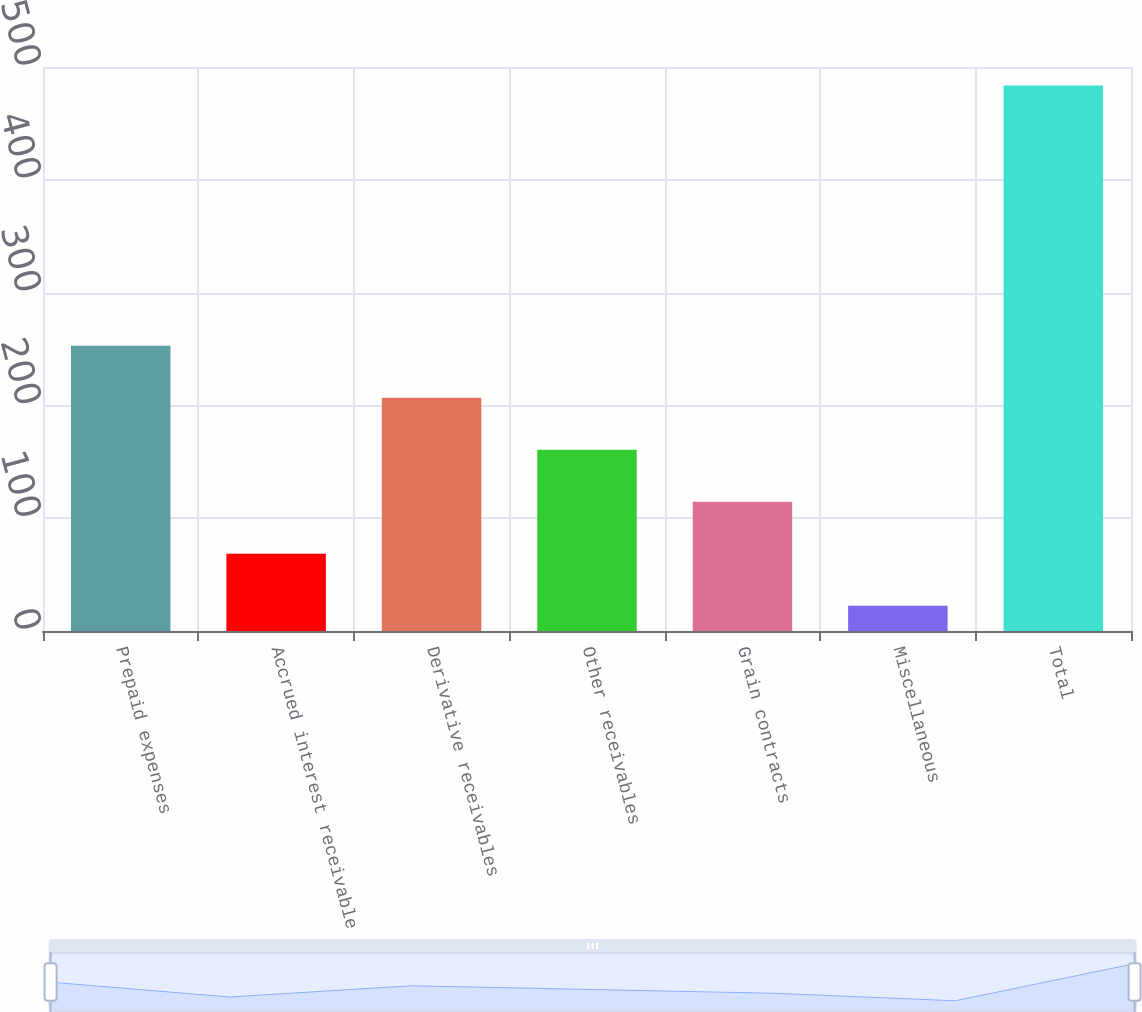Convert chart. <chart><loc_0><loc_0><loc_500><loc_500><bar_chart><fcel>Prepaid expenses<fcel>Accrued interest receivable<fcel>Derivative receivables<fcel>Other receivables<fcel>Grain contracts<fcel>Miscellaneous<fcel>Total<nl><fcel>252.95<fcel>68.51<fcel>206.84<fcel>160.73<fcel>114.62<fcel>22.4<fcel>483.5<nl></chart> 